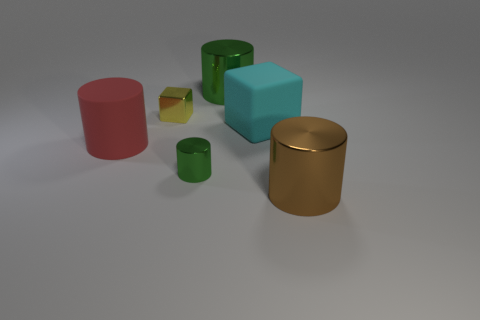There is a cyan block; is it the same size as the green metal thing that is in front of the yellow block?
Your answer should be compact. No. There is a green metal object in front of the big object to the left of the cylinder behind the big red object; how big is it?
Your answer should be compact. Small. How many blocks are left of the large rubber cube?
Keep it short and to the point. 1. What is the material of the cylinder in front of the green metal object to the left of the big green thing?
Your answer should be compact. Metal. Is the size of the brown metallic cylinder the same as the yellow metal object?
Provide a short and direct response. No. How many objects are large metallic cylinders to the right of the large green shiny thing or shiny objects behind the big red rubber cylinder?
Your answer should be compact. 3. Are there more objects to the right of the small metal cube than tiny shiny cylinders?
Keep it short and to the point. Yes. What number of other things are the same shape as the brown thing?
Provide a succinct answer. 3. The big cylinder that is in front of the large cyan thing and behind the brown cylinder is made of what material?
Keep it short and to the point. Rubber. How many objects are either tiny green things or tiny balls?
Provide a succinct answer. 1. 